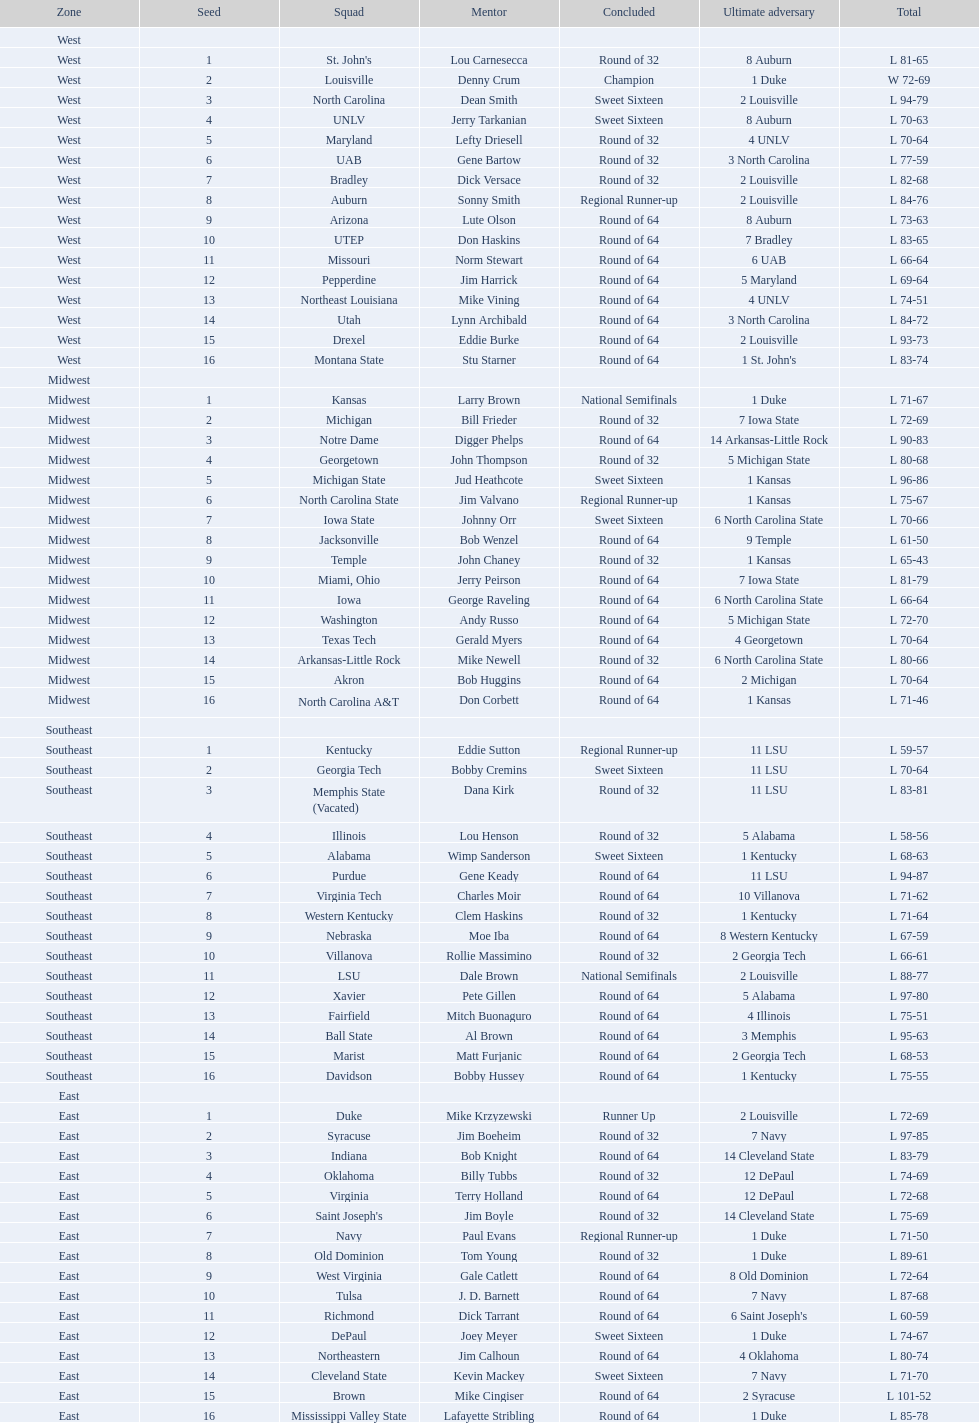Which team from the east region managed to make it to the final round? Duke. Write the full table. {'header': ['Zone', 'Seed', 'Squad', 'Mentor', 'Concluded', 'Ultimate adversary', 'Total'], 'rows': [['West', '', '', '', '', '', ''], ['West', '1', "St. John's", 'Lou Carnesecca', 'Round of 32', '8 Auburn', 'L 81-65'], ['West', '2', 'Louisville', 'Denny Crum', 'Champion', '1 Duke', 'W 72-69'], ['West', '3', 'North Carolina', 'Dean Smith', 'Sweet Sixteen', '2 Louisville', 'L 94-79'], ['West', '4', 'UNLV', 'Jerry Tarkanian', 'Sweet Sixteen', '8 Auburn', 'L 70-63'], ['West', '5', 'Maryland', 'Lefty Driesell', 'Round of 32', '4 UNLV', 'L 70-64'], ['West', '6', 'UAB', 'Gene Bartow', 'Round of 32', '3 North Carolina', 'L 77-59'], ['West', '7', 'Bradley', 'Dick Versace', 'Round of 32', '2 Louisville', 'L 82-68'], ['West', '8', 'Auburn', 'Sonny Smith', 'Regional Runner-up', '2 Louisville', 'L 84-76'], ['West', '9', 'Arizona', 'Lute Olson', 'Round of 64', '8 Auburn', 'L 73-63'], ['West', '10', 'UTEP', 'Don Haskins', 'Round of 64', '7 Bradley', 'L 83-65'], ['West', '11', 'Missouri', 'Norm Stewart', 'Round of 64', '6 UAB', 'L 66-64'], ['West', '12', 'Pepperdine', 'Jim Harrick', 'Round of 64', '5 Maryland', 'L 69-64'], ['West', '13', 'Northeast Louisiana', 'Mike Vining', 'Round of 64', '4 UNLV', 'L 74-51'], ['West', '14', 'Utah', 'Lynn Archibald', 'Round of 64', '3 North Carolina', 'L 84-72'], ['West', '15', 'Drexel', 'Eddie Burke', 'Round of 64', '2 Louisville', 'L 93-73'], ['West', '16', 'Montana State', 'Stu Starner', 'Round of 64', "1 St. John's", 'L 83-74'], ['Midwest', '', '', '', '', '', ''], ['Midwest', '1', 'Kansas', 'Larry Brown', 'National Semifinals', '1 Duke', 'L 71-67'], ['Midwest', '2', 'Michigan', 'Bill Frieder', 'Round of 32', '7 Iowa State', 'L 72-69'], ['Midwest', '3', 'Notre Dame', 'Digger Phelps', 'Round of 64', '14 Arkansas-Little Rock', 'L 90-83'], ['Midwest', '4', 'Georgetown', 'John Thompson', 'Round of 32', '5 Michigan State', 'L 80-68'], ['Midwest', '5', 'Michigan State', 'Jud Heathcote', 'Sweet Sixteen', '1 Kansas', 'L 96-86'], ['Midwest', '6', 'North Carolina State', 'Jim Valvano', 'Regional Runner-up', '1 Kansas', 'L 75-67'], ['Midwest', '7', 'Iowa State', 'Johnny Orr', 'Sweet Sixteen', '6 North Carolina State', 'L 70-66'], ['Midwest', '8', 'Jacksonville', 'Bob Wenzel', 'Round of 64', '9 Temple', 'L 61-50'], ['Midwest', '9', 'Temple', 'John Chaney', 'Round of 32', '1 Kansas', 'L 65-43'], ['Midwest', '10', 'Miami, Ohio', 'Jerry Peirson', 'Round of 64', '7 Iowa State', 'L 81-79'], ['Midwest', '11', 'Iowa', 'George Raveling', 'Round of 64', '6 North Carolina State', 'L 66-64'], ['Midwest', '12', 'Washington', 'Andy Russo', 'Round of 64', '5 Michigan State', 'L 72-70'], ['Midwest', '13', 'Texas Tech', 'Gerald Myers', 'Round of 64', '4 Georgetown', 'L 70-64'], ['Midwest', '14', 'Arkansas-Little Rock', 'Mike Newell', 'Round of 32', '6 North Carolina State', 'L 80-66'], ['Midwest', '15', 'Akron', 'Bob Huggins', 'Round of 64', '2 Michigan', 'L 70-64'], ['Midwest', '16', 'North Carolina A&T', 'Don Corbett', 'Round of 64', '1 Kansas', 'L 71-46'], ['Southeast', '', '', '', '', '', ''], ['Southeast', '1', 'Kentucky', 'Eddie Sutton', 'Regional Runner-up', '11 LSU', 'L 59-57'], ['Southeast', '2', 'Georgia Tech', 'Bobby Cremins', 'Sweet Sixteen', '11 LSU', 'L 70-64'], ['Southeast', '3', 'Memphis State (Vacated)', 'Dana Kirk', 'Round of 32', '11 LSU', 'L 83-81'], ['Southeast', '4', 'Illinois', 'Lou Henson', 'Round of 32', '5 Alabama', 'L 58-56'], ['Southeast', '5', 'Alabama', 'Wimp Sanderson', 'Sweet Sixteen', '1 Kentucky', 'L 68-63'], ['Southeast', '6', 'Purdue', 'Gene Keady', 'Round of 64', '11 LSU', 'L 94-87'], ['Southeast', '7', 'Virginia Tech', 'Charles Moir', 'Round of 64', '10 Villanova', 'L 71-62'], ['Southeast', '8', 'Western Kentucky', 'Clem Haskins', 'Round of 32', '1 Kentucky', 'L 71-64'], ['Southeast', '9', 'Nebraska', 'Moe Iba', 'Round of 64', '8 Western Kentucky', 'L 67-59'], ['Southeast', '10', 'Villanova', 'Rollie Massimino', 'Round of 32', '2 Georgia Tech', 'L 66-61'], ['Southeast', '11', 'LSU', 'Dale Brown', 'National Semifinals', '2 Louisville', 'L 88-77'], ['Southeast', '12', 'Xavier', 'Pete Gillen', 'Round of 64', '5 Alabama', 'L 97-80'], ['Southeast', '13', 'Fairfield', 'Mitch Buonaguro', 'Round of 64', '4 Illinois', 'L 75-51'], ['Southeast', '14', 'Ball State', 'Al Brown', 'Round of 64', '3 Memphis', 'L 95-63'], ['Southeast', '15', 'Marist', 'Matt Furjanic', 'Round of 64', '2 Georgia Tech', 'L 68-53'], ['Southeast', '16', 'Davidson', 'Bobby Hussey', 'Round of 64', '1 Kentucky', 'L 75-55'], ['East', '', '', '', '', '', ''], ['East', '1', 'Duke', 'Mike Krzyzewski', 'Runner Up', '2 Louisville', 'L 72-69'], ['East', '2', 'Syracuse', 'Jim Boeheim', 'Round of 32', '7 Navy', 'L 97-85'], ['East', '3', 'Indiana', 'Bob Knight', 'Round of 64', '14 Cleveland State', 'L 83-79'], ['East', '4', 'Oklahoma', 'Billy Tubbs', 'Round of 32', '12 DePaul', 'L 74-69'], ['East', '5', 'Virginia', 'Terry Holland', 'Round of 64', '12 DePaul', 'L 72-68'], ['East', '6', "Saint Joseph's", 'Jim Boyle', 'Round of 32', '14 Cleveland State', 'L 75-69'], ['East', '7', 'Navy', 'Paul Evans', 'Regional Runner-up', '1 Duke', 'L 71-50'], ['East', '8', 'Old Dominion', 'Tom Young', 'Round of 32', '1 Duke', 'L 89-61'], ['East', '9', 'West Virginia', 'Gale Catlett', 'Round of 64', '8 Old Dominion', 'L 72-64'], ['East', '10', 'Tulsa', 'J. D. Barnett', 'Round of 64', '7 Navy', 'L 87-68'], ['East', '11', 'Richmond', 'Dick Tarrant', 'Round of 64', "6 Saint Joseph's", 'L 60-59'], ['East', '12', 'DePaul', 'Joey Meyer', 'Sweet Sixteen', '1 Duke', 'L 74-67'], ['East', '13', 'Northeastern', 'Jim Calhoun', 'Round of 64', '4 Oklahoma', 'L 80-74'], ['East', '14', 'Cleveland State', 'Kevin Mackey', 'Sweet Sixteen', '7 Navy', 'L 71-70'], ['East', '15', 'Brown', 'Mike Cingiser', 'Round of 64', '2 Syracuse', 'L 101-52'], ['East', '16', 'Mississippi Valley State', 'Lafayette Stribling', 'Round of 64', '1 Duke', 'L 85-78']]} 